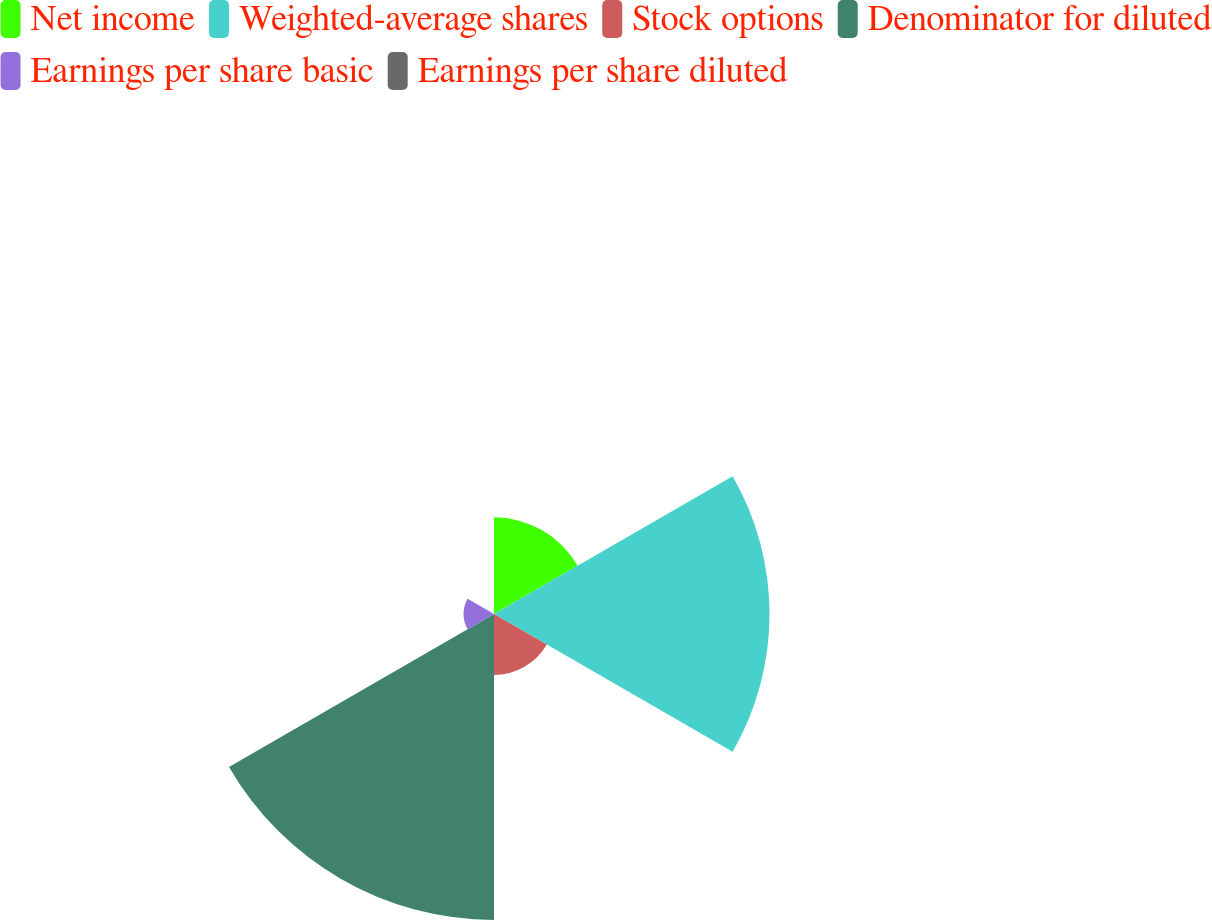Convert chart. <chart><loc_0><loc_0><loc_500><loc_500><pie_chart><fcel>Net income<fcel>Weighted-average shares<fcel>Stock options<fcel>Denominator for diluted<fcel>Earnings per share basic<fcel>Earnings per share diluted<nl><fcel>12.56%<fcel>35.8%<fcel>7.92%<fcel>39.76%<fcel>3.96%<fcel>0.0%<nl></chart> 